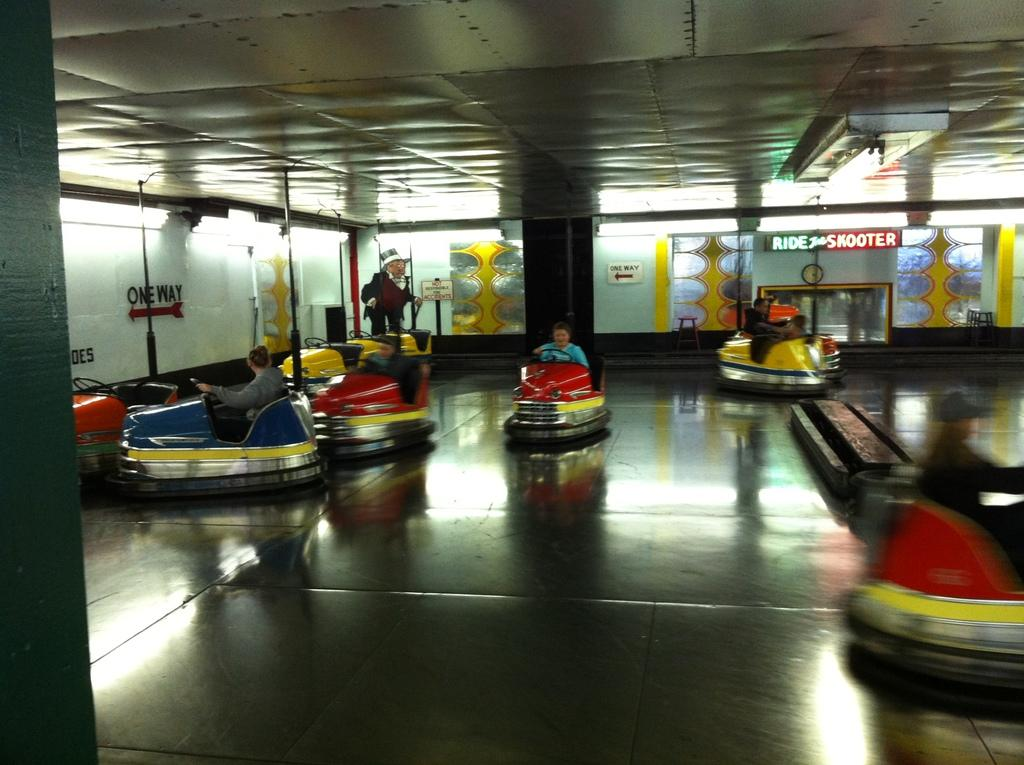What are the people in the image doing? The people in the image are riding cars. What colors are the cars? The cars are in red, yellow, and blue colors. What can be seen in the background of the image? There are boards and glasses visible in the background. How does the pump affect the pleasure of the people in the image? There is no pump present in the image, so it cannot affect the pleasure of the people. 